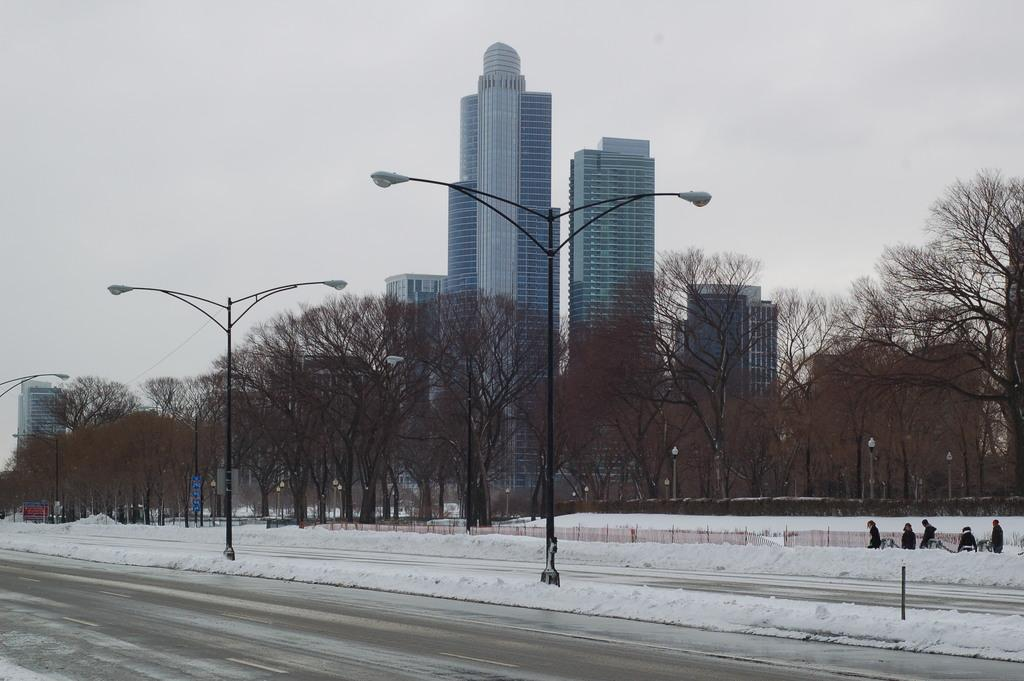What is located in the foreground of the image? There are street lights in the foreground of the image. Where are the street lights positioned in relation to the road? The street lights are placed next to the road. What can be seen in the background of the image? There are buildings, trees, persons walking on the snow, and the sky visible in the background of the image. What type of agreement can be seen between the apples and the dress in the image? There are no apples or dresses present in the image, so there is no agreement to be observed. 